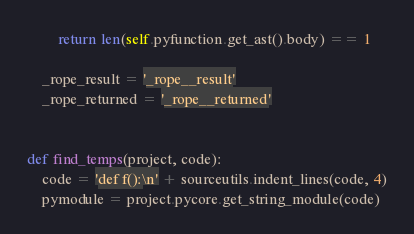<code> <loc_0><loc_0><loc_500><loc_500><_Python_>        return len(self.pyfunction.get_ast().body) == 1

    _rope_result = '_rope__result'
    _rope_returned = '_rope__returned'


def find_temps(project, code):
    code = 'def f():\n' + sourceutils.indent_lines(code, 4)
    pymodule = project.pycore.get_string_module(code)</code> 